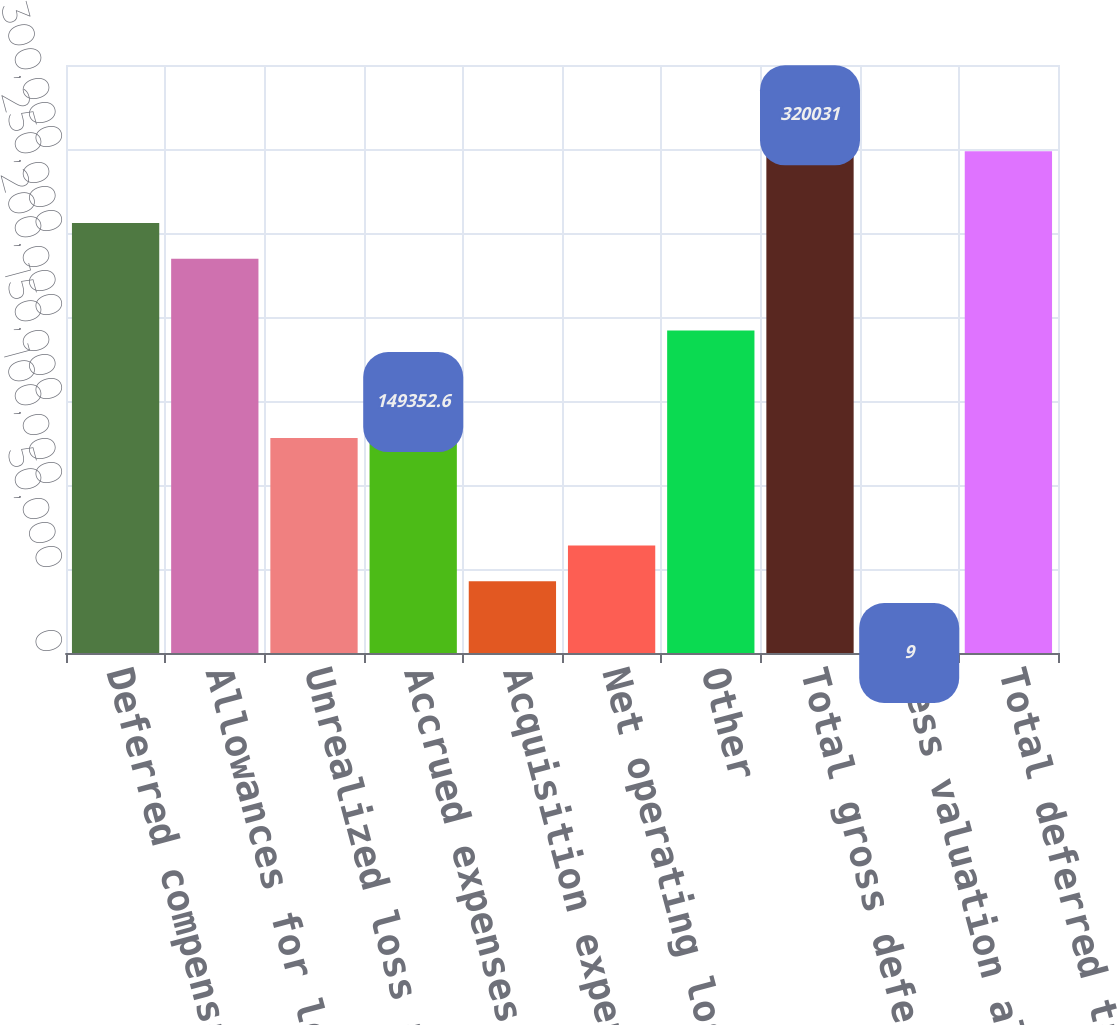Convert chart to OTSL. <chart><loc_0><loc_0><loc_500><loc_500><bar_chart><fcel>Deferred compensation<fcel>Allowances for loan losses and<fcel>Unrealized loss associated<fcel>Accrued expenses<fcel>Acquisition expense<fcel>Net operating loss and credit<fcel>Other<fcel>Total gross deferred tax<fcel>Less valuation allowance<fcel>Total deferred tax assets<nl><fcel>256027<fcel>234692<fcel>128018<fcel>149353<fcel>42678.6<fcel>64013.4<fcel>192022<fcel>320031<fcel>9<fcel>298696<nl></chart> 